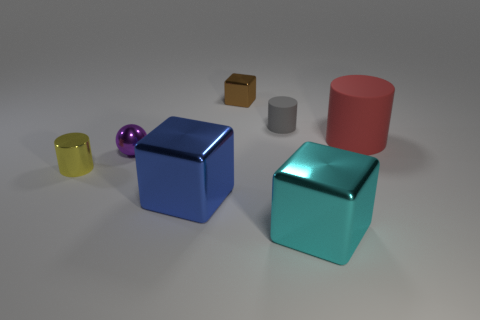There is a shiny block that is in front of the big blue cube; what is its size?
Your response must be concise. Large. Are there more metal spheres than rubber things?
Ensure brevity in your answer.  No. What is the material of the large cylinder?
Your answer should be compact. Rubber. How many other things are the same material as the small purple object?
Offer a terse response. 4. How many big purple shiny things are there?
Keep it short and to the point. 0. What material is the brown object that is the same shape as the blue thing?
Offer a terse response. Metal. Are the cube in front of the large blue metallic object and the small purple sphere made of the same material?
Ensure brevity in your answer.  Yes. Are there more big cyan things that are in front of the big cylinder than tiny gray things behind the purple thing?
Offer a terse response. No. The gray object has what size?
Offer a terse response. Small. There is a yellow object that is the same material as the small brown cube; what shape is it?
Ensure brevity in your answer.  Cylinder. 